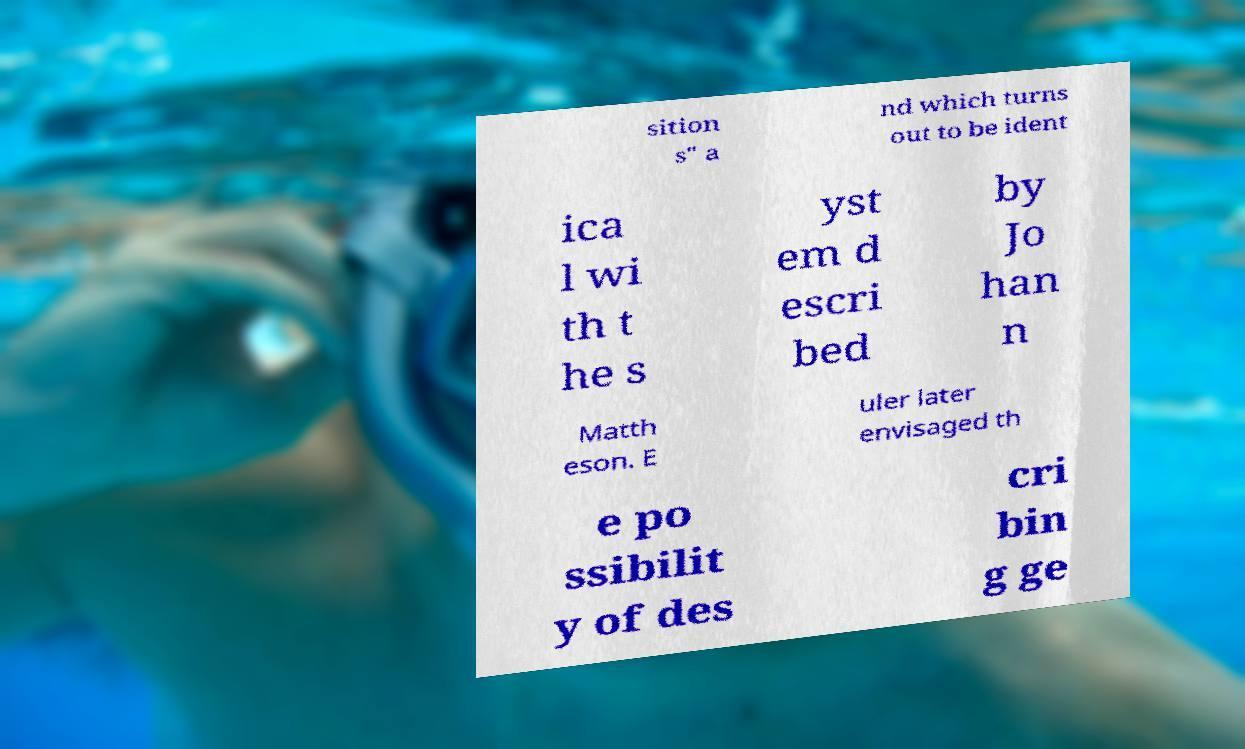There's text embedded in this image that I need extracted. Can you transcribe it verbatim? sition s" a nd which turns out to be ident ica l wi th t he s yst em d escri bed by Jo han n Matth eson. E uler later envisaged th e po ssibilit y of des cri bin g ge 